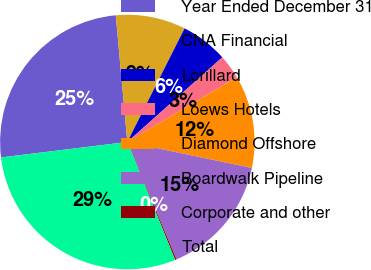<chart> <loc_0><loc_0><loc_500><loc_500><pie_chart><fcel>Year Ended December 31<fcel>CNA Financial<fcel>Lorillard<fcel>Loews Hotels<fcel>Diamond Offshore<fcel>Boardwalk Pipeline<fcel>Corporate and other<fcel>Total<nl><fcel>25.49%<fcel>8.88%<fcel>5.98%<fcel>3.08%<fcel>11.78%<fcel>15.42%<fcel>0.18%<fcel>29.19%<nl></chart> 